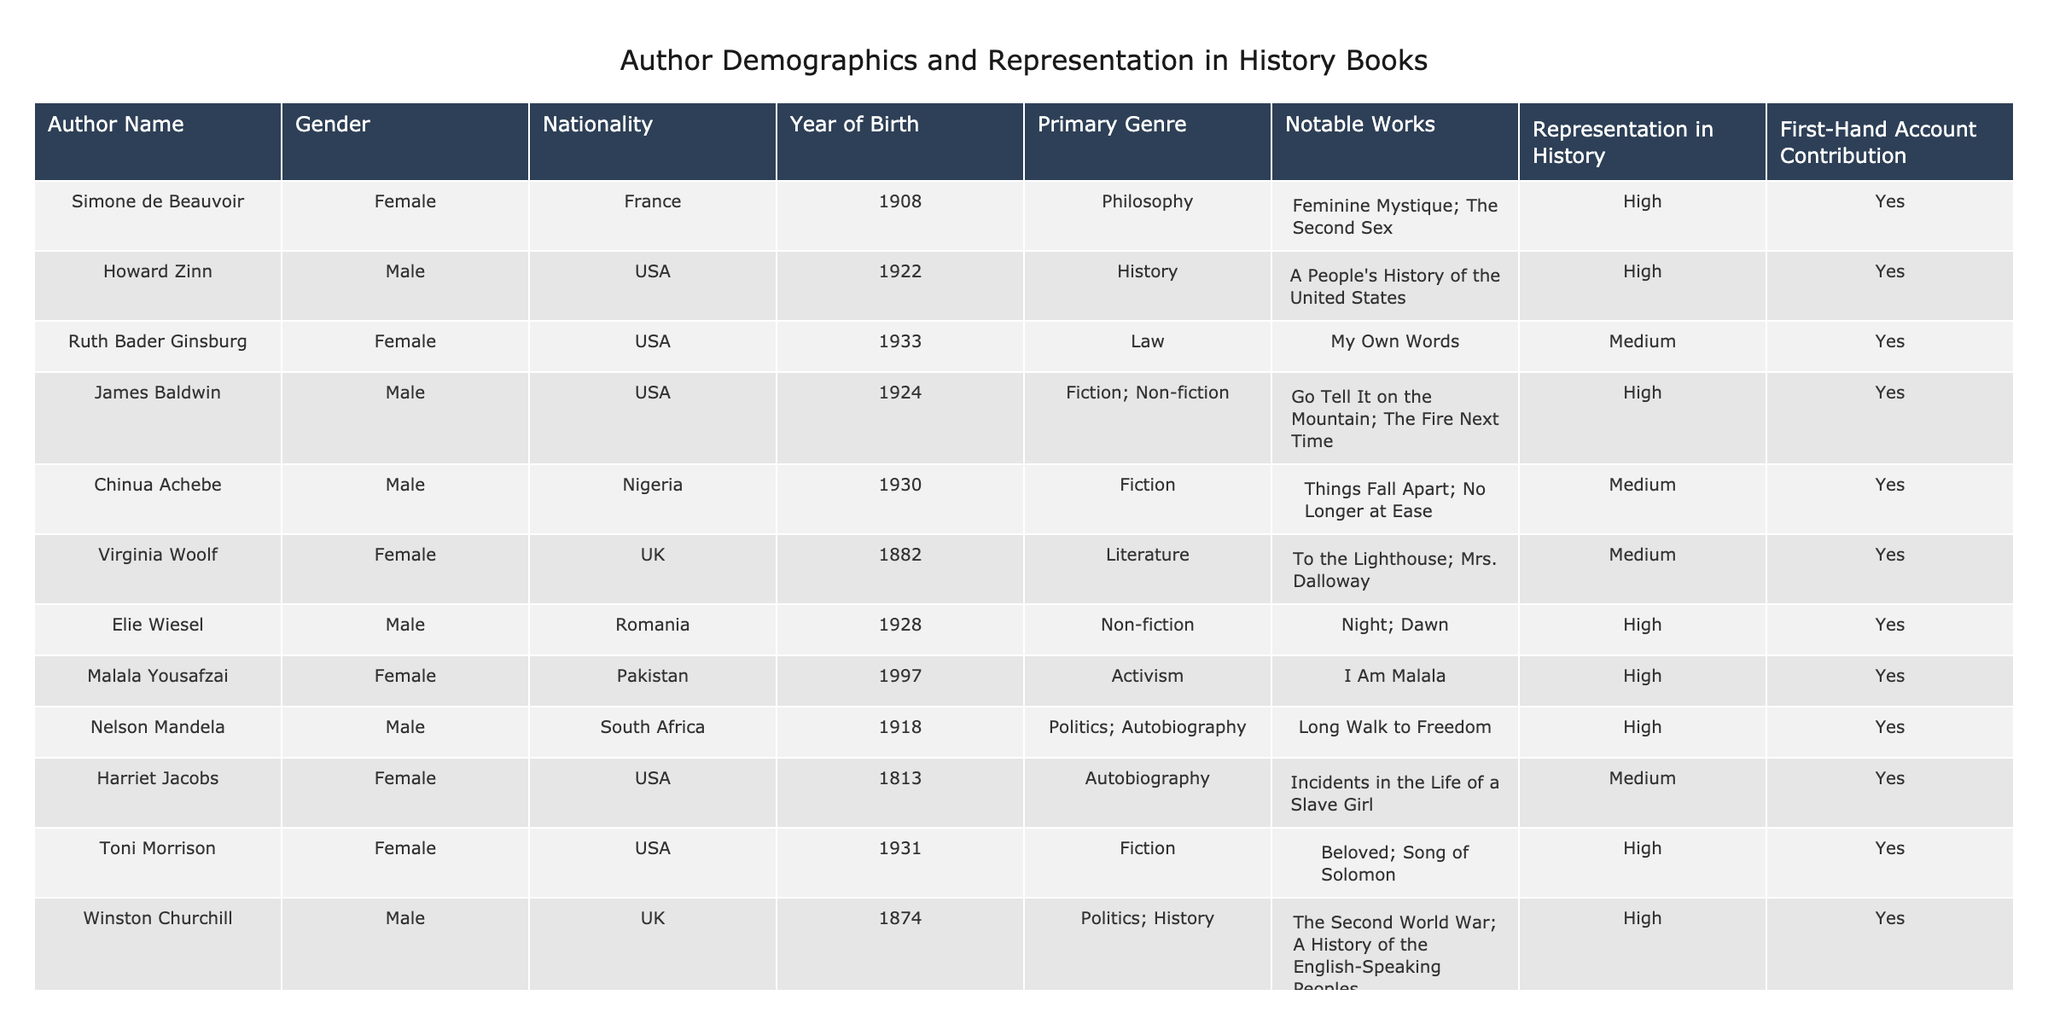What is the gender distribution of the authors in the table? There are a total of 14 authors in the table. Out of these, 6 are female, and 8 are male. Therefore, the gender distribution is 6 female and 8 male authors.
Answer: 6 female, 8 male Which author is known for the work "Things Fall Apart"? The author known for "Things Fall Apart" is Chinua Achebe, as indicated in the table where notable works are listed.
Answer: Chinua Achebe How many authors contributed first-hand accounts in history? There are 10 authors in the table who contributed first-hand accounts, as indicated by a "Yes" in the "First-Hand Account Contribution" column.
Answer: 10 Is Ruth Bader Ginsburg represented as a high contributor in history books? Ruth Bader Ginsburg's representation in history is indicated as "Medium," which means she is not categorized as a high contributor.
Answer: No Who are the authors with a high representation in history from the USA? The authors with a high representation in history from the USA are Howard Zinn, Ruth Bader Ginsburg, James Baldwin, Elie Wiesel, Malala Yousafzai, and Toni Morrison. This can be identified by filtering the table for "High" representation and the nationality "USA."
Answer: Howard Zinn, James Baldwin, Elie Wiesel, Malala Yousafzai, Toni Morrison What is the average year of birth of female authors in the table? The female authors in the table are Simone de Beauvoir (1908), Ruth Bader Ginsburg (1933), Virginia Woolf (1882), Malala Yousafzai (1997), Harriet Jacobs (1813), and Toni Morrison (1931). Their birth years are summed (1908 + 1933 + 1882 + 1997 + 1813 + 1931 = 11864), and divided by 6, resulting in an average year of 1977.33, which can be rounded down to 1977.
Answer: 1977 Are there more authors from Africa or Europe represented in the table? There are 2 authors from Africa (Chinua Achebe and Nelson Mandela) and 5 from Europe (Simone de Beauvoir, Virginia Woolf, Winston Churchill, George Orwell, and Frida Kahlo). Since 5 is greater than 2, there are more authors from Europe.
Answer: Europe Which author's notable works include "Night"? The author whose notable works include "Night" is Elie Wiesel, as per the information in the notable works section of the table.
Answer: Elie Wiesel How many authors have a primary genre of Fiction and also high representation in history? The authors with a primary genre of Fiction and high representation in history are James Baldwin and Toni Morrison. By checking the "Primary Genre" and "Representation" columns, we can determine this.
Answer: 2 